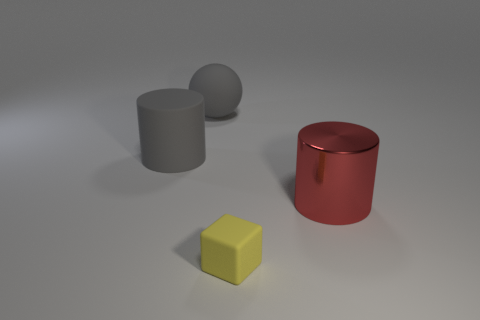How many matte objects are either balls or small cylinders?
Provide a short and direct response. 1. Is the number of large green matte spheres less than the number of large cylinders?
Provide a succinct answer. Yes. Does the yellow cube have the same size as the gray sphere behind the tiny yellow matte thing?
Keep it short and to the point. No. Is there anything else that has the same shape as the small yellow matte thing?
Ensure brevity in your answer.  No. What size is the red object?
Your answer should be compact. Large. Is the number of gray objects in front of the small yellow block less than the number of tiny objects?
Offer a terse response. Yes. Is the gray rubber ball the same size as the rubber cube?
Your answer should be compact. No. Are there any other things that are the same size as the gray ball?
Give a very brief answer. Yes. The ball that is made of the same material as the cube is what color?
Provide a succinct answer. Gray. Is the number of gray cylinders that are in front of the yellow rubber block less than the number of things that are left of the gray rubber cylinder?
Your response must be concise. No. 